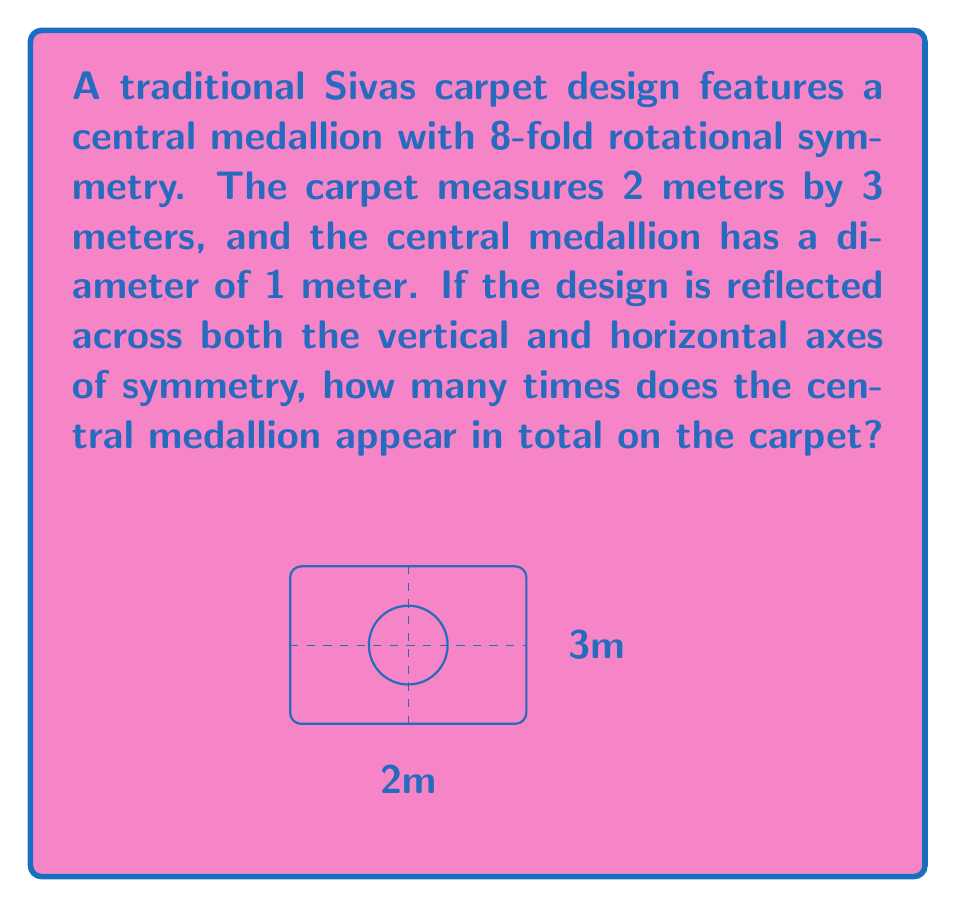Give your solution to this math problem. Let's approach this step-by-step:

1) First, we need to understand what symmetry operations are being applied:
   - The carpet has both vertical and horizontal axes of symmetry
   - This means the design is reflected across both axes

2) When a design is reflected across two perpendicular axes, it creates 4 identical quadrants.

3) In each quadrant, we will see a full central medallion:
   $$4 \text{ quadrants} \times 1 \text{ medallion} = 4 \text{ medallions}$$

4) However, we also need to consider the original medallion in the center:
   $$4 \text{ reflected medallions} + 1 \text{ original medallion} = 5 \text{ medallions}$$

5) The 8-fold rotational symmetry of the medallion itself doesn't affect the total count of medallions, but it's an interesting feature of the design that reflects the rich geometric patterns typical in Sivas carpets.

Therefore, after applying the reflections across both axes of symmetry, the central medallion will appear 5 times in total on the carpet.
Answer: 5 medallions 